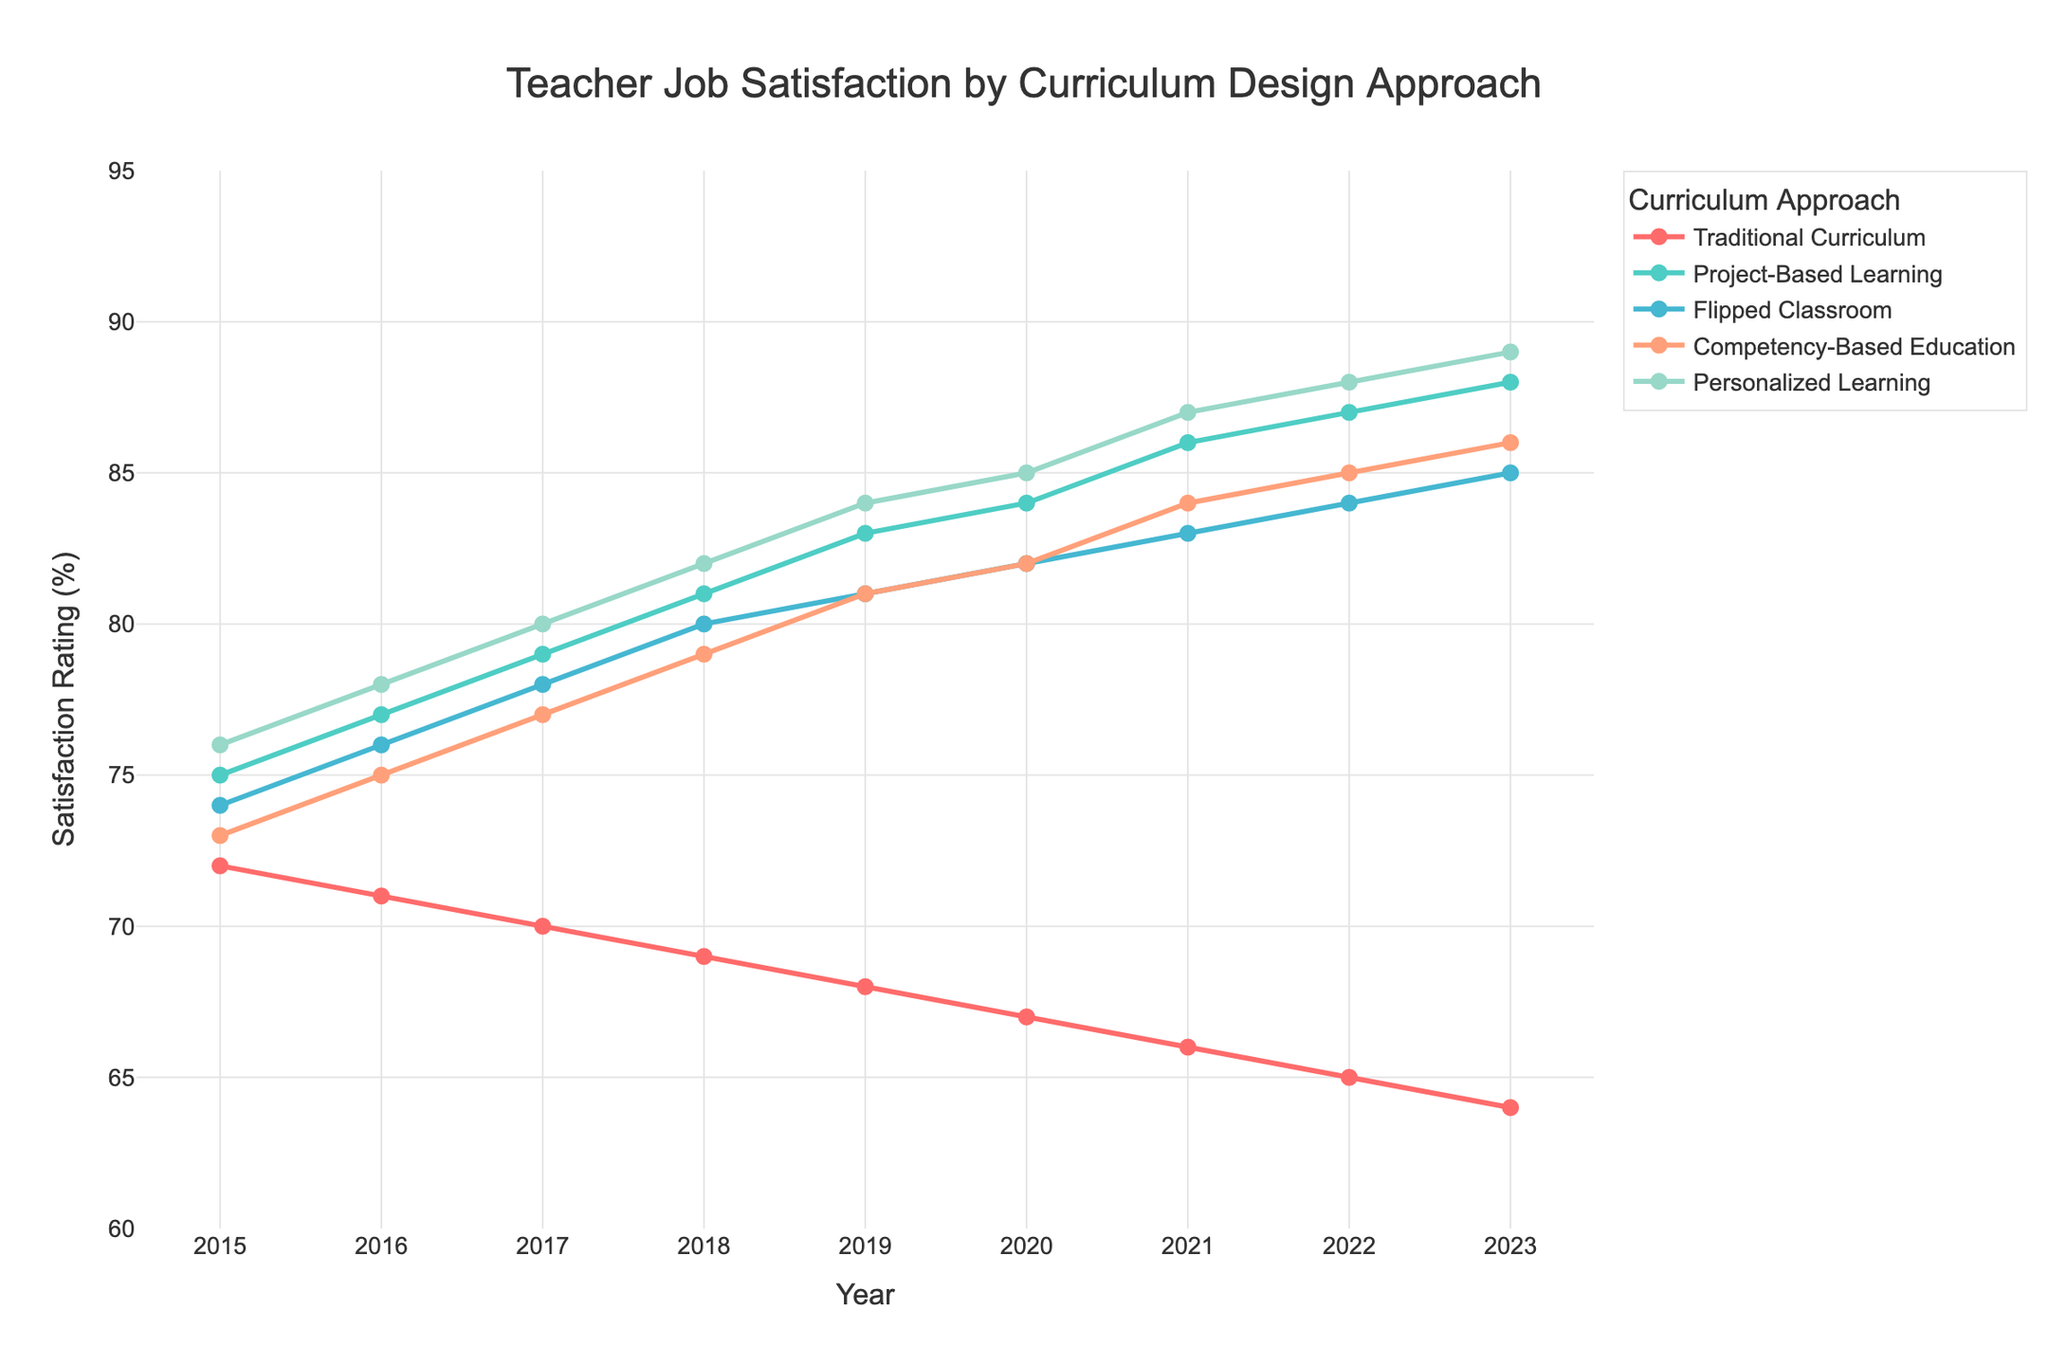What is the overall trend in teacher job satisfaction for the Traditional Curriculum from 2015 to 2023? The Traditional Curriculum shows a downward trend in teacher job satisfaction from 2015 to 2023. It starts at a satisfaction rating of 72% in 2015 and gradually decreases each year, reaching 64% in 2023.
Answer: Downward trend Which curriculum design approach had the highest teacher job satisfaction rating in 2023? Look at the satisfaction ratings for all curriculum design approaches in 2023. The ratings are: Traditional Curriculum (64%), Project-Based Learning (88%), Flipped Classroom (85%), Competency-Based Education (86%), and Personalized Learning (89%). The highest rating is for Personalized Learning at 89%.
Answer: Personalized Learning What was the difference in teacher job satisfaction between Project-Based Learning and Flipped Classroom in 2017? In 2017, the satisfaction for Project-Based Learning was 79% and for Flipped Classroom was 78%. The difference is calculated as 79% - 78% = 1%.
Answer: 1% Which curriculum design approach experienced the largest increase in teacher job satisfaction from 2015 to 2023? Calculate the increase for each curriculum by subtracting the 2015 rating from the 2023 rating. Traditional Curriculum (64 - 72 = -8), Project-Based Learning (88 - 75 = 13), Flipped Classroom (85 - 74 = 11), Competency-Based Education (86 - 73 = 13), Personalized Learning (89 - 76 = 13). The largest increase is observed in Project-Based Learning, Competency-Based Education, and Personalized Learning, all with an increase of 13%.
Answer: Project-Based Learning, Competency-Based Education, Personalized Learning Between which consecutive years did the Competency-Based Education show the greatest increase in teacher job satisfaction? Calculate the yearly differences for Competency-Based Education: 2016-2015 (75-73=2), 2017-2016 (77-75=2), 2018-2017 (79-77=2), 2019-2018 (81-79=2), 2020-2019 (82-81=1), 2021-2020 (84-82=2), 2022-2021 (85-84=1), 2023-2022 (86-85=1). The greatest increase is between any of the following consecutive years: 2015-2016, 2016-2017, 2017-2018, 2018-2019, or 2021-2022, all showing an increase of 2%.
Answer: Multiple consecutive years (2015-2016, 2016-2017, 2017-2018, 2018-2019, or 2021-2022), all 2% How does the satisfaction rating of the Flipped Classroom in 2020 compare to the Traditional Curriculum in 2015? In 2020, the satisfaction rating for the Flipped Classroom is 82%, and for Traditional Curriculum in 2015, it is 72%. The Flipped Classroom has a higher rating by 10%.
Answer: Higher by 10% What's the average teacher job satisfaction rating for Personalized Learning across all years? Add the satisfaction ratings for Personalized Learning from 2015 to 2023 and divide by the number of years: (76+78+80+82+84+85+87+88+89)/9 = (749/9) ≈ 83.22.
Answer: 83.22 